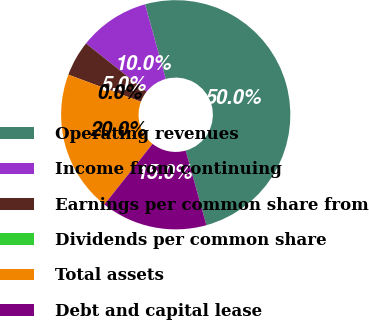Convert chart. <chart><loc_0><loc_0><loc_500><loc_500><pie_chart><fcel>Operating revenues<fcel>Income from continuing<fcel>Earnings per common share from<fcel>Dividends per common share<fcel>Total assets<fcel>Debt and capital lease<nl><fcel>50.0%<fcel>10.0%<fcel>5.0%<fcel>0.0%<fcel>20.0%<fcel>15.0%<nl></chart> 